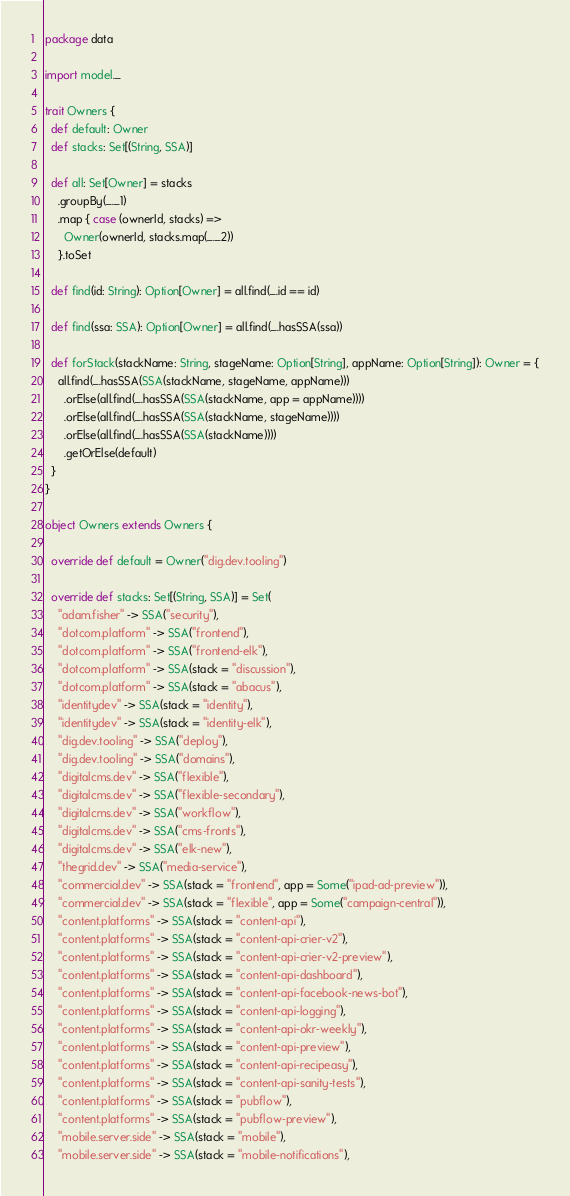Convert code to text. <code><loc_0><loc_0><loc_500><loc_500><_Scala_>package data

import model._

trait Owners {
  def default: Owner
  def stacks: Set[(String, SSA)]

  def all: Set[Owner] = stacks
    .groupBy(_._1)
    .map { case (ownerId, stacks) =>
      Owner(ownerId, stacks.map(_._2))
    }.toSet

  def find(id: String): Option[Owner] = all.find(_.id == id)

  def find(ssa: SSA): Option[Owner] = all.find(_.hasSSA(ssa))

  def forStack(stackName: String, stageName: Option[String], appName: Option[String]): Owner = {
    all.find(_.hasSSA(SSA(stackName, stageName, appName)))
      .orElse(all.find(_.hasSSA(SSA(stackName, app = appName))))
      .orElse(all.find(_.hasSSA(SSA(stackName, stageName))))
      .orElse(all.find(_.hasSSA(SSA(stackName))))
      .getOrElse(default)
  }
}

object Owners extends Owners {

  override def default = Owner("dig.dev.tooling")

  override def stacks: Set[(String, SSA)] = Set(
    "adam.fisher" -> SSA("security"),
    "dotcom.platform" -> SSA("frontend"),
    "dotcom.platform" -> SSA("frontend-elk"),
    "dotcom.platform" -> SSA(stack = "discussion"),
    "dotcom.platform" -> SSA(stack = "abacus"),
    "identitydev" -> SSA(stack = "identity"),
    "identitydev" -> SSA(stack = "identity-elk"),
    "dig.dev.tooling" -> SSA("deploy"),
    "dig.dev.tooling" -> SSA("domains"),
    "digitalcms.dev" -> SSA("flexible"),
    "digitalcms.dev" -> SSA("flexible-secondary"),
    "digitalcms.dev" -> SSA("workflow"),
    "digitalcms.dev" -> SSA("cms-fronts"),
    "digitalcms.dev" -> SSA("elk-new"),
    "thegrid.dev" -> SSA("media-service"),
    "commercial.dev" -> SSA(stack = "frontend", app = Some("ipad-ad-preview")),
    "commercial.dev" -> SSA(stack = "flexible", app = Some("campaign-central")),
    "content.platforms" -> SSA(stack = "content-api"),
    "content.platforms" -> SSA(stack = "content-api-crier-v2"),
    "content.platforms" -> SSA(stack = "content-api-crier-v2-preview"),
    "content.platforms" -> SSA(stack = "content-api-dashboard"),
    "content.platforms" -> SSA(stack = "content-api-facebook-news-bot"),
    "content.platforms" -> SSA(stack = "content-api-logging"),
    "content.platforms" -> SSA(stack = "content-api-okr-weekly"),
    "content.platforms" -> SSA(stack = "content-api-preview"),
    "content.platforms" -> SSA(stack = "content-api-recipeasy"),
    "content.platforms" -> SSA(stack = "content-api-sanity-tests"),
    "content.platforms" -> SSA(stack = "pubflow"),
    "content.platforms" -> SSA(stack = "pubflow-preview"),
    "mobile.server.side" -> SSA(stack = "mobile"),
    "mobile.server.side" -> SSA(stack = "mobile-notifications"),</code> 